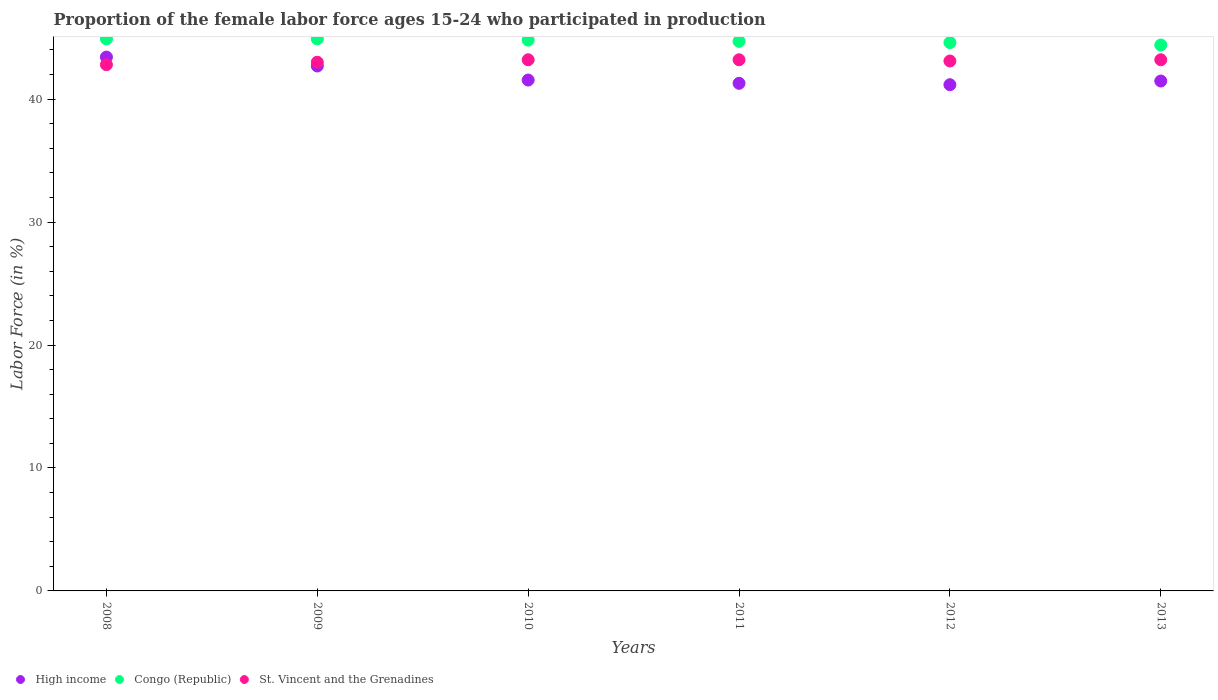How many different coloured dotlines are there?
Make the answer very short. 3. What is the proportion of the female labor force who participated in production in High income in 2009?
Ensure brevity in your answer.  42.69. Across all years, what is the maximum proportion of the female labor force who participated in production in Congo (Republic)?
Make the answer very short. 44.9. Across all years, what is the minimum proportion of the female labor force who participated in production in High income?
Offer a terse response. 41.17. In which year was the proportion of the female labor force who participated in production in Congo (Republic) minimum?
Your response must be concise. 2013. What is the total proportion of the female labor force who participated in production in Congo (Republic) in the graph?
Give a very brief answer. 268.3. What is the difference between the proportion of the female labor force who participated in production in St. Vincent and the Grenadines in 2009 and that in 2012?
Offer a very short reply. -0.1. What is the difference between the proportion of the female labor force who participated in production in St. Vincent and the Grenadines in 2008 and the proportion of the female labor force who participated in production in Congo (Republic) in 2009?
Ensure brevity in your answer.  -2.1. What is the average proportion of the female labor force who participated in production in Congo (Republic) per year?
Give a very brief answer. 44.72. In the year 2012, what is the difference between the proportion of the female labor force who participated in production in Congo (Republic) and proportion of the female labor force who participated in production in High income?
Ensure brevity in your answer.  3.43. What is the ratio of the proportion of the female labor force who participated in production in St. Vincent and the Grenadines in 2008 to that in 2012?
Provide a short and direct response. 0.99. Is the proportion of the female labor force who participated in production in Congo (Republic) in 2010 less than that in 2012?
Keep it short and to the point. No. Is the difference between the proportion of the female labor force who participated in production in Congo (Republic) in 2011 and 2012 greater than the difference between the proportion of the female labor force who participated in production in High income in 2011 and 2012?
Your response must be concise. No. What is the difference between the highest and the second highest proportion of the female labor force who participated in production in Congo (Republic)?
Give a very brief answer. 0. What is the difference between the highest and the lowest proportion of the female labor force who participated in production in Congo (Republic)?
Your answer should be very brief. 0.5. Is it the case that in every year, the sum of the proportion of the female labor force who participated in production in Congo (Republic) and proportion of the female labor force who participated in production in St. Vincent and the Grenadines  is greater than the proportion of the female labor force who participated in production in High income?
Make the answer very short. Yes. Does the proportion of the female labor force who participated in production in Congo (Republic) monotonically increase over the years?
Give a very brief answer. No. Is the proportion of the female labor force who participated in production in High income strictly greater than the proportion of the female labor force who participated in production in St. Vincent and the Grenadines over the years?
Provide a succinct answer. No. How many dotlines are there?
Provide a short and direct response. 3. How many years are there in the graph?
Offer a very short reply. 6. What is the difference between two consecutive major ticks on the Y-axis?
Your response must be concise. 10. Does the graph contain any zero values?
Offer a very short reply. No. Where does the legend appear in the graph?
Your response must be concise. Bottom left. How are the legend labels stacked?
Give a very brief answer. Horizontal. What is the title of the graph?
Provide a succinct answer. Proportion of the female labor force ages 15-24 who participated in production. What is the label or title of the X-axis?
Your answer should be compact. Years. What is the Labor Force (in %) in High income in 2008?
Your answer should be compact. 43.42. What is the Labor Force (in %) of Congo (Republic) in 2008?
Offer a very short reply. 44.9. What is the Labor Force (in %) of St. Vincent and the Grenadines in 2008?
Offer a very short reply. 42.8. What is the Labor Force (in %) of High income in 2009?
Your response must be concise. 42.69. What is the Labor Force (in %) of Congo (Republic) in 2009?
Your answer should be compact. 44.9. What is the Labor Force (in %) of St. Vincent and the Grenadines in 2009?
Provide a succinct answer. 43. What is the Labor Force (in %) in High income in 2010?
Offer a terse response. 41.55. What is the Labor Force (in %) in Congo (Republic) in 2010?
Your response must be concise. 44.8. What is the Labor Force (in %) in St. Vincent and the Grenadines in 2010?
Your answer should be very brief. 43.2. What is the Labor Force (in %) in High income in 2011?
Make the answer very short. 41.28. What is the Labor Force (in %) in Congo (Republic) in 2011?
Provide a succinct answer. 44.7. What is the Labor Force (in %) in St. Vincent and the Grenadines in 2011?
Your answer should be very brief. 43.2. What is the Labor Force (in %) of High income in 2012?
Your answer should be very brief. 41.17. What is the Labor Force (in %) in Congo (Republic) in 2012?
Provide a succinct answer. 44.6. What is the Labor Force (in %) of St. Vincent and the Grenadines in 2012?
Provide a succinct answer. 43.1. What is the Labor Force (in %) in High income in 2013?
Provide a short and direct response. 41.47. What is the Labor Force (in %) of Congo (Republic) in 2013?
Provide a short and direct response. 44.4. What is the Labor Force (in %) in St. Vincent and the Grenadines in 2013?
Your answer should be compact. 43.2. Across all years, what is the maximum Labor Force (in %) in High income?
Provide a succinct answer. 43.42. Across all years, what is the maximum Labor Force (in %) in Congo (Republic)?
Make the answer very short. 44.9. Across all years, what is the maximum Labor Force (in %) in St. Vincent and the Grenadines?
Your response must be concise. 43.2. Across all years, what is the minimum Labor Force (in %) of High income?
Give a very brief answer. 41.17. Across all years, what is the minimum Labor Force (in %) of Congo (Republic)?
Your answer should be very brief. 44.4. Across all years, what is the minimum Labor Force (in %) of St. Vincent and the Grenadines?
Offer a terse response. 42.8. What is the total Labor Force (in %) of High income in the graph?
Provide a succinct answer. 251.59. What is the total Labor Force (in %) in Congo (Republic) in the graph?
Your answer should be very brief. 268.3. What is the total Labor Force (in %) in St. Vincent and the Grenadines in the graph?
Your answer should be compact. 258.5. What is the difference between the Labor Force (in %) of High income in 2008 and that in 2009?
Ensure brevity in your answer.  0.72. What is the difference between the Labor Force (in %) of St. Vincent and the Grenadines in 2008 and that in 2009?
Offer a very short reply. -0.2. What is the difference between the Labor Force (in %) in High income in 2008 and that in 2010?
Your answer should be very brief. 1.87. What is the difference between the Labor Force (in %) of High income in 2008 and that in 2011?
Keep it short and to the point. 2.13. What is the difference between the Labor Force (in %) in Congo (Republic) in 2008 and that in 2011?
Keep it short and to the point. 0.2. What is the difference between the Labor Force (in %) in High income in 2008 and that in 2012?
Make the answer very short. 2.25. What is the difference between the Labor Force (in %) in Congo (Republic) in 2008 and that in 2012?
Ensure brevity in your answer.  0.3. What is the difference between the Labor Force (in %) in High income in 2008 and that in 2013?
Provide a succinct answer. 1.95. What is the difference between the Labor Force (in %) of High income in 2009 and that in 2010?
Provide a short and direct response. 1.14. What is the difference between the Labor Force (in %) in Congo (Republic) in 2009 and that in 2010?
Your answer should be compact. 0.1. What is the difference between the Labor Force (in %) in High income in 2009 and that in 2011?
Provide a succinct answer. 1.41. What is the difference between the Labor Force (in %) in Congo (Republic) in 2009 and that in 2011?
Provide a short and direct response. 0.2. What is the difference between the Labor Force (in %) of High income in 2009 and that in 2012?
Your answer should be compact. 1.52. What is the difference between the Labor Force (in %) of Congo (Republic) in 2009 and that in 2012?
Your answer should be compact. 0.3. What is the difference between the Labor Force (in %) in St. Vincent and the Grenadines in 2009 and that in 2012?
Keep it short and to the point. -0.1. What is the difference between the Labor Force (in %) of High income in 2009 and that in 2013?
Your answer should be very brief. 1.22. What is the difference between the Labor Force (in %) of Congo (Republic) in 2009 and that in 2013?
Your answer should be compact. 0.5. What is the difference between the Labor Force (in %) in High income in 2010 and that in 2011?
Provide a succinct answer. 0.27. What is the difference between the Labor Force (in %) of Congo (Republic) in 2010 and that in 2011?
Make the answer very short. 0.1. What is the difference between the Labor Force (in %) of St. Vincent and the Grenadines in 2010 and that in 2011?
Your answer should be compact. 0. What is the difference between the Labor Force (in %) in High income in 2010 and that in 2012?
Offer a very short reply. 0.38. What is the difference between the Labor Force (in %) of St. Vincent and the Grenadines in 2010 and that in 2012?
Your answer should be compact. 0.1. What is the difference between the Labor Force (in %) in High income in 2010 and that in 2013?
Keep it short and to the point. 0.08. What is the difference between the Labor Force (in %) in High income in 2011 and that in 2012?
Your answer should be very brief. 0.11. What is the difference between the Labor Force (in %) of Congo (Republic) in 2011 and that in 2012?
Offer a terse response. 0.1. What is the difference between the Labor Force (in %) in High income in 2011 and that in 2013?
Ensure brevity in your answer.  -0.19. What is the difference between the Labor Force (in %) of High income in 2012 and that in 2013?
Keep it short and to the point. -0.3. What is the difference between the Labor Force (in %) of High income in 2008 and the Labor Force (in %) of Congo (Republic) in 2009?
Make the answer very short. -1.48. What is the difference between the Labor Force (in %) in High income in 2008 and the Labor Force (in %) in St. Vincent and the Grenadines in 2009?
Offer a very short reply. 0.42. What is the difference between the Labor Force (in %) of Congo (Republic) in 2008 and the Labor Force (in %) of St. Vincent and the Grenadines in 2009?
Offer a terse response. 1.9. What is the difference between the Labor Force (in %) in High income in 2008 and the Labor Force (in %) in Congo (Republic) in 2010?
Provide a succinct answer. -1.38. What is the difference between the Labor Force (in %) in High income in 2008 and the Labor Force (in %) in St. Vincent and the Grenadines in 2010?
Keep it short and to the point. 0.22. What is the difference between the Labor Force (in %) in Congo (Republic) in 2008 and the Labor Force (in %) in St. Vincent and the Grenadines in 2010?
Make the answer very short. 1.7. What is the difference between the Labor Force (in %) of High income in 2008 and the Labor Force (in %) of Congo (Republic) in 2011?
Provide a short and direct response. -1.28. What is the difference between the Labor Force (in %) of High income in 2008 and the Labor Force (in %) of St. Vincent and the Grenadines in 2011?
Your response must be concise. 0.22. What is the difference between the Labor Force (in %) of Congo (Republic) in 2008 and the Labor Force (in %) of St. Vincent and the Grenadines in 2011?
Offer a terse response. 1.7. What is the difference between the Labor Force (in %) of High income in 2008 and the Labor Force (in %) of Congo (Republic) in 2012?
Offer a very short reply. -1.18. What is the difference between the Labor Force (in %) in High income in 2008 and the Labor Force (in %) in St. Vincent and the Grenadines in 2012?
Make the answer very short. 0.32. What is the difference between the Labor Force (in %) in Congo (Republic) in 2008 and the Labor Force (in %) in St. Vincent and the Grenadines in 2012?
Keep it short and to the point. 1.8. What is the difference between the Labor Force (in %) in High income in 2008 and the Labor Force (in %) in Congo (Republic) in 2013?
Provide a succinct answer. -0.98. What is the difference between the Labor Force (in %) in High income in 2008 and the Labor Force (in %) in St. Vincent and the Grenadines in 2013?
Ensure brevity in your answer.  0.22. What is the difference between the Labor Force (in %) in High income in 2009 and the Labor Force (in %) in Congo (Republic) in 2010?
Make the answer very short. -2.11. What is the difference between the Labor Force (in %) in High income in 2009 and the Labor Force (in %) in St. Vincent and the Grenadines in 2010?
Your answer should be compact. -0.51. What is the difference between the Labor Force (in %) of Congo (Republic) in 2009 and the Labor Force (in %) of St. Vincent and the Grenadines in 2010?
Ensure brevity in your answer.  1.7. What is the difference between the Labor Force (in %) in High income in 2009 and the Labor Force (in %) in Congo (Republic) in 2011?
Give a very brief answer. -2.01. What is the difference between the Labor Force (in %) in High income in 2009 and the Labor Force (in %) in St. Vincent and the Grenadines in 2011?
Keep it short and to the point. -0.51. What is the difference between the Labor Force (in %) of Congo (Republic) in 2009 and the Labor Force (in %) of St. Vincent and the Grenadines in 2011?
Your response must be concise. 1.7. What is the difference between the Labor Force (in %) of High income in 2009 and the Labor Force (in %) of Congo (Republic) in 2012?
Offer a terse response. -1.91. What is the difference between the Labor Force (in %) of High income in 2009 and the Labor Force (in %) of St. Vincent and the Grenadines in 2012?
Offer a very short reply. -0.41. What is the difference between the Labor Force (in %) of High income in 2009 and the Labor Force (in %) of Congo (Republic) in 2013?
Give a very brief answer. -1.71. What is the difference between the Labor Force (in %) of High income in 2009 and the Labor Force (in %) of St. Vincent and the Grenadines in 2013?
Your response must be concise. -0.51. What is the difference between the Labor Force (in %) of Congo (Republic) in 2009 and the Labor Force (in %) of St. Vincent and the Grenadines in 2013?
Offer a terse response. 1.7. What is the difference between the Labor Force (in %) of High income in 2010 and the Labor Force (in %) of Congo (Republic) in 2011?
Give a very brief answer. -3.15. What is the difference between the Labor Force (in %) in High income in 2010 and the Labor Force (in %) in St. Vincent and the Grenadines in 2011?
Offer a very short reply. -1.65. What is the difference between the Labor Force (in %) of Congo (Republic) in 2010 and the Labor Force (in %) of St. Vincent and the Grenadines in 2011?
Ensure brevity in your answer.  1.6. What is the difference between the Labor Force (in %) of High income in 2010 and the Labor Force (in %) of Congo (Republic) in 2012?
Your response must be concise. -3.05. What is the difference between the Labor Force (in %) of High income in 2010 and the Labor Force (in %) of St. Vincent and the Grenadines in 2012?
Keep it short and to the point. -1.55. What is the difference between the Labor Force (in %) in High income in 2010 and the Labor Force (in %) in Congo (Republic) in 2013?
Keep it short and to the point. -2.85. What is the difference between the Labor Force (in %) in High income in 2010 and the Labor Force (in %) in St. Vincent and the Grenadines in 2013?
Your answer should be compact. -1.65. What is the difference between the Labor Force (in %) of High income in 2011 and the Labor Force (in %) of Congo (Republic) in 2012?
Offer a very short reply. -3.32. What is the difference between the Labor Force (in %) of High income in 2011 and the Labor Force (in %) of St. Vincent and the Grenadines in 2012?
Make the answer very short. -1.82. What is the difference between the Labor Force (in %) in Congo (Republic) in 2011 and the Labor Force (in %) in St. Vincent and the Grenadines in 2012?
Your response must be concise. 1.6. What is the difference between the Labor Force (in %) in High income in 2011 and the Labor Force (in %) in Congo (Republic) in 2013?
Your response must be concise. -3.12. What is the difference between the Labor Force (in %) of High income in 2011 and the Labor Force (in %) of St. Vincent and the Grenadines in 2013?
Keep it short and to the point. -1.92. What is the difference between the Labor Force (in %) in High income in 2012 and the Labor Force (in %) in Congo (Republic) in 2013?
Your answer should be compact. -3.23. What is the difference between the Labor Force (in %) of High income in 2012 and the Labor Force (in %) of St. Vincent and the Grenadines in 2013?
Keep it short and to the point. -2.03. What is the average Labor Force (in %) of High income per year?
Offer a very short reply. 41.93. What is the average Labor Force (in %) of Congo (Republic) per year?
Provide a short and direct response. 44.72. What is the average Labor Force (in %) in St. Vincent and the Grenadines per year?
Offer a very short reply. 43.08. In the year 2008, what is the difference between the Labor Force (in %) of High income and Labor Force (in %) of Congo (Republic)?
Keep it short and to the point. -1.48. In the year 2008, what is the difference between the Labor Force (in %) in High income and Labor Force (in %) in St. Vincent and the Grenadines?
Make the answer very short. 0.62. In the year 2008, what is the difference between the Labor Force (in %) in Congo (Republic) and Labor Force (in %) in St. Vincent and the Grenadines?
Offer a very short reply. 2.1. In the year 2009, what is the difference between the Labor Force (in %) of High income and Labor Force (in %) of Congo (Republic)?
Your answer should be very brief. -2.21. In the year 2009, what is the difference between the Labor Force (in %) of High income and Labor Force (in %) of St. Vincent and the Grenadines?
Provide a short and direct response. -0.31. In the year 2009, what is the difference between the Labor Force (in %) in Congo (Republic) and Labor Force (in %) in St. Vincent and the Grenadines?
Your answer should be compact. 1.9. In the year 2010, what is the difference between the Labor Force (in %) in High income and Labor Force (in %) in Congo (Republic)?
Give a very brief answer. -3.25. In the year 2010, what is the difference between the Labor Force (in %) of High income and Labor Force (in %) of St. Vincent and the Grenadines?
Your answer should be very brief. -1.65. In the year 2011, what is the difference between the Labor Force (in %) in High income and Labor Force (in %) in Congo (Republic)?
Offer a very short reply. -3.42. In the year 2011, what is the difference between the Labor Force (in %) in High income and Labor Force (in %) in St. Vincent and the Grenadines?
Give a very brief answer. -1.92. In the year 2011, what is the difference between the Labor Force (in %) of Congo (Republic) and Labor Force (in %) of St. Vincent and the Grenadines?
Provide a short and direct response. 1.5. In the year 2012, what is the difference between the Labor Force (in %) in High income and Labor Force (in %) in Congo (Republic)?
Keep it short and to the point. -3.43. In the year 2012, what is the difference between the Labor Force (in %) of High income and Labor Force (in %) of St. Vincent and the Grenadines?
Offer a terse response. -1.93. In the year 2013, what is the difference between the Labor Force (in %) of High income and Labor Force (in %) of Congo (Republic)?
Your response must be concise. -2.93. In the year 2013, what is the difference between the Labor Force (in %) of High income and Labor Force (in %) of St. Vincent and the Grenadines?
Provide a short and direct response. -1.73. In the year 2013, what is the difference between the Labor Force (in %) of Congo (Republic) and Labor Force (in %) of St. Vincent and the Grenadines?
Keep it short and to the point. 1.2. What is the ratio of the Labor Force (in %) in Congo (Republic) in 2008 to that in 2009?
Provide a succinct answer. 1. What is the ratio of the Labor Force (in %) of St. Vincent and the Grenadines in 2008 to that in 2009?
Give a very brief answer. 1. What is the ratio of the Labor Force (in %) in High income in 2008 to that in 2010?
Provide a succinct answer. 1.04. What is the ratio of the Labor Force (in %) of Congo (Republic) in 2008 to that in 2010?
Ensure brevity in your answer.  1. What is the ratio of the Labor Force (in %) of High income in 2008 to that in 2011?
Ensure brevity in your answer.  1.05. What is the ratio of the Labor Force (in %) in Congo (Republic) in 2008 to that in 2011?
Ensure brevity in your answer.  1. What is the ratio of the Labor Force (in %) of St. Vincent and the Grenadines in 2008 to that in 2011?
Your answer should be very brief. 0.99. What is the ratio of the Labor Force (in %) in High income in 2008 to that in 2012?
Offer a very short reply. 1.05. What is the ratio of the Labor Force (in %) of High income in 2008 to that in 2013?
Keep it short and to the point. 1.05. What is the ratio of the Labor Force (in %) in Congo (Republic) in 2008 to that in 2013?
Keep it short and to the point. 1.01. What is the ratio of the Labor Force (in %) in High income in 2009 to that in 2010?
Offer a very short reply. 1.03. What is the ratio of the Labor Force (in %) of St. Vincent and the Grenadines in 2009 to that in 2010?
Provide a short and direct response. 1. What is the ratio of the Labor Force (in %) of High income in 2009 to that in 2011?
Give a very brief answer. 1.03. What is the ratio of the Labor Force (in %) of Congo (Republic) in 2009 to that in 2011?
Offer a terse response. 1. What is the ratio of the Labor Force (in %) in High income in 2009 to that in 2012?
Your answer should be compact. 1.04. What is the ratio of the Labor Force (in %) in High income in 2009 to that in 2013?
Provide a short and direct response. 1.03. What is the ratio of the Labor Force (in %) in Congo (Republic) in 2009 to that in 2013?
Ensure brevity in your answer.  1.01. What is the ratio of the Labor Force (in %) of St. Vincent and the Grenadines in 2010 to that in 2011?
Your answer should be compact. 1. What is the ratio of the Labor Force (in %) in High income in 2010 to that in 2012?
Provide a succinct answer. 1.01. What is the ratio of the Labor Force (in %) in Congo (Republic) in 2010 to that in 2012?
Keep it short and to the point. 1. What is the ratio of the Labor Force (in %) of High income in 2010 to that in 2013?
Your answer should be very brief. 1. What is the ratio of the Labor Force (in %) of Congo (Republic) in 2011 to that in 2012?
Offer a terse response. 1. What is the ratio of the Labor Force (in %) in St. Vincent and the Grenadines in 2011 to that in 2012?
Provide a short and direct response. 1. What is the ratio of the Labor Force (in %) of High income in 2011 to that in 2013?
Provide a short and direct response. 1. What is the ratio of the Labor Force (in %) in Congo (Republic) in 2011 to that in 2013?
Provide a short and direct response. 1.01. What is the ratio of the Labor Force (in %) in St. Vincent and the Grenadines in 2011 to that in 2013?
Your answer should be very brief. 1. What is the ratio of the Labor Force (in %) in Congo (Republic) in 2012 to that in 2013?
Offer a terse response. 1. What is the difference between the highest and the second highest Labor Force (in %) in High income?
Ensure brevity in your answer.  0.72. What is the difference between the highest and the second highest Labor Force (in %) in Congo (Republic)?
Your answer should be very brief. 0. What is the difference between the highest and the lowest Labor Force (in %) of High income?
Offer a very short reply. 2.25. What is the difference between the highest and the lowest Labor Force (in %) of Congo (Republic)?
Give a very brief answer. 0.5. 